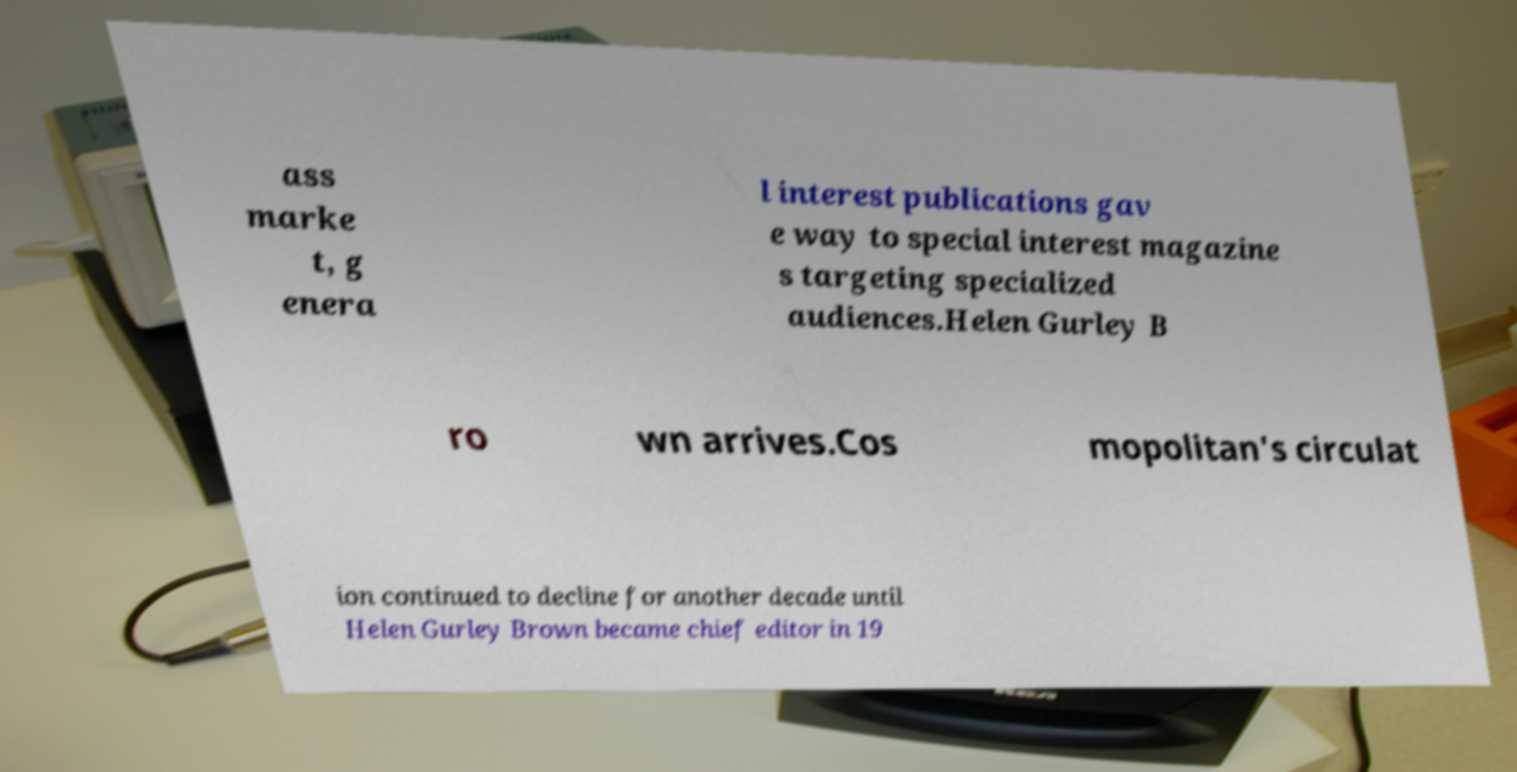Please read and relay the text visible in this image. What does it say? ass marke t, g enera l interest publications gav e way to special interest magazine s targeting specialized audiences.Helen Gurley B ro wn arrives.Cos mopolitan's circulat ion continued to decline for another decade until Helen Gurley Brown became chief editor in 19 